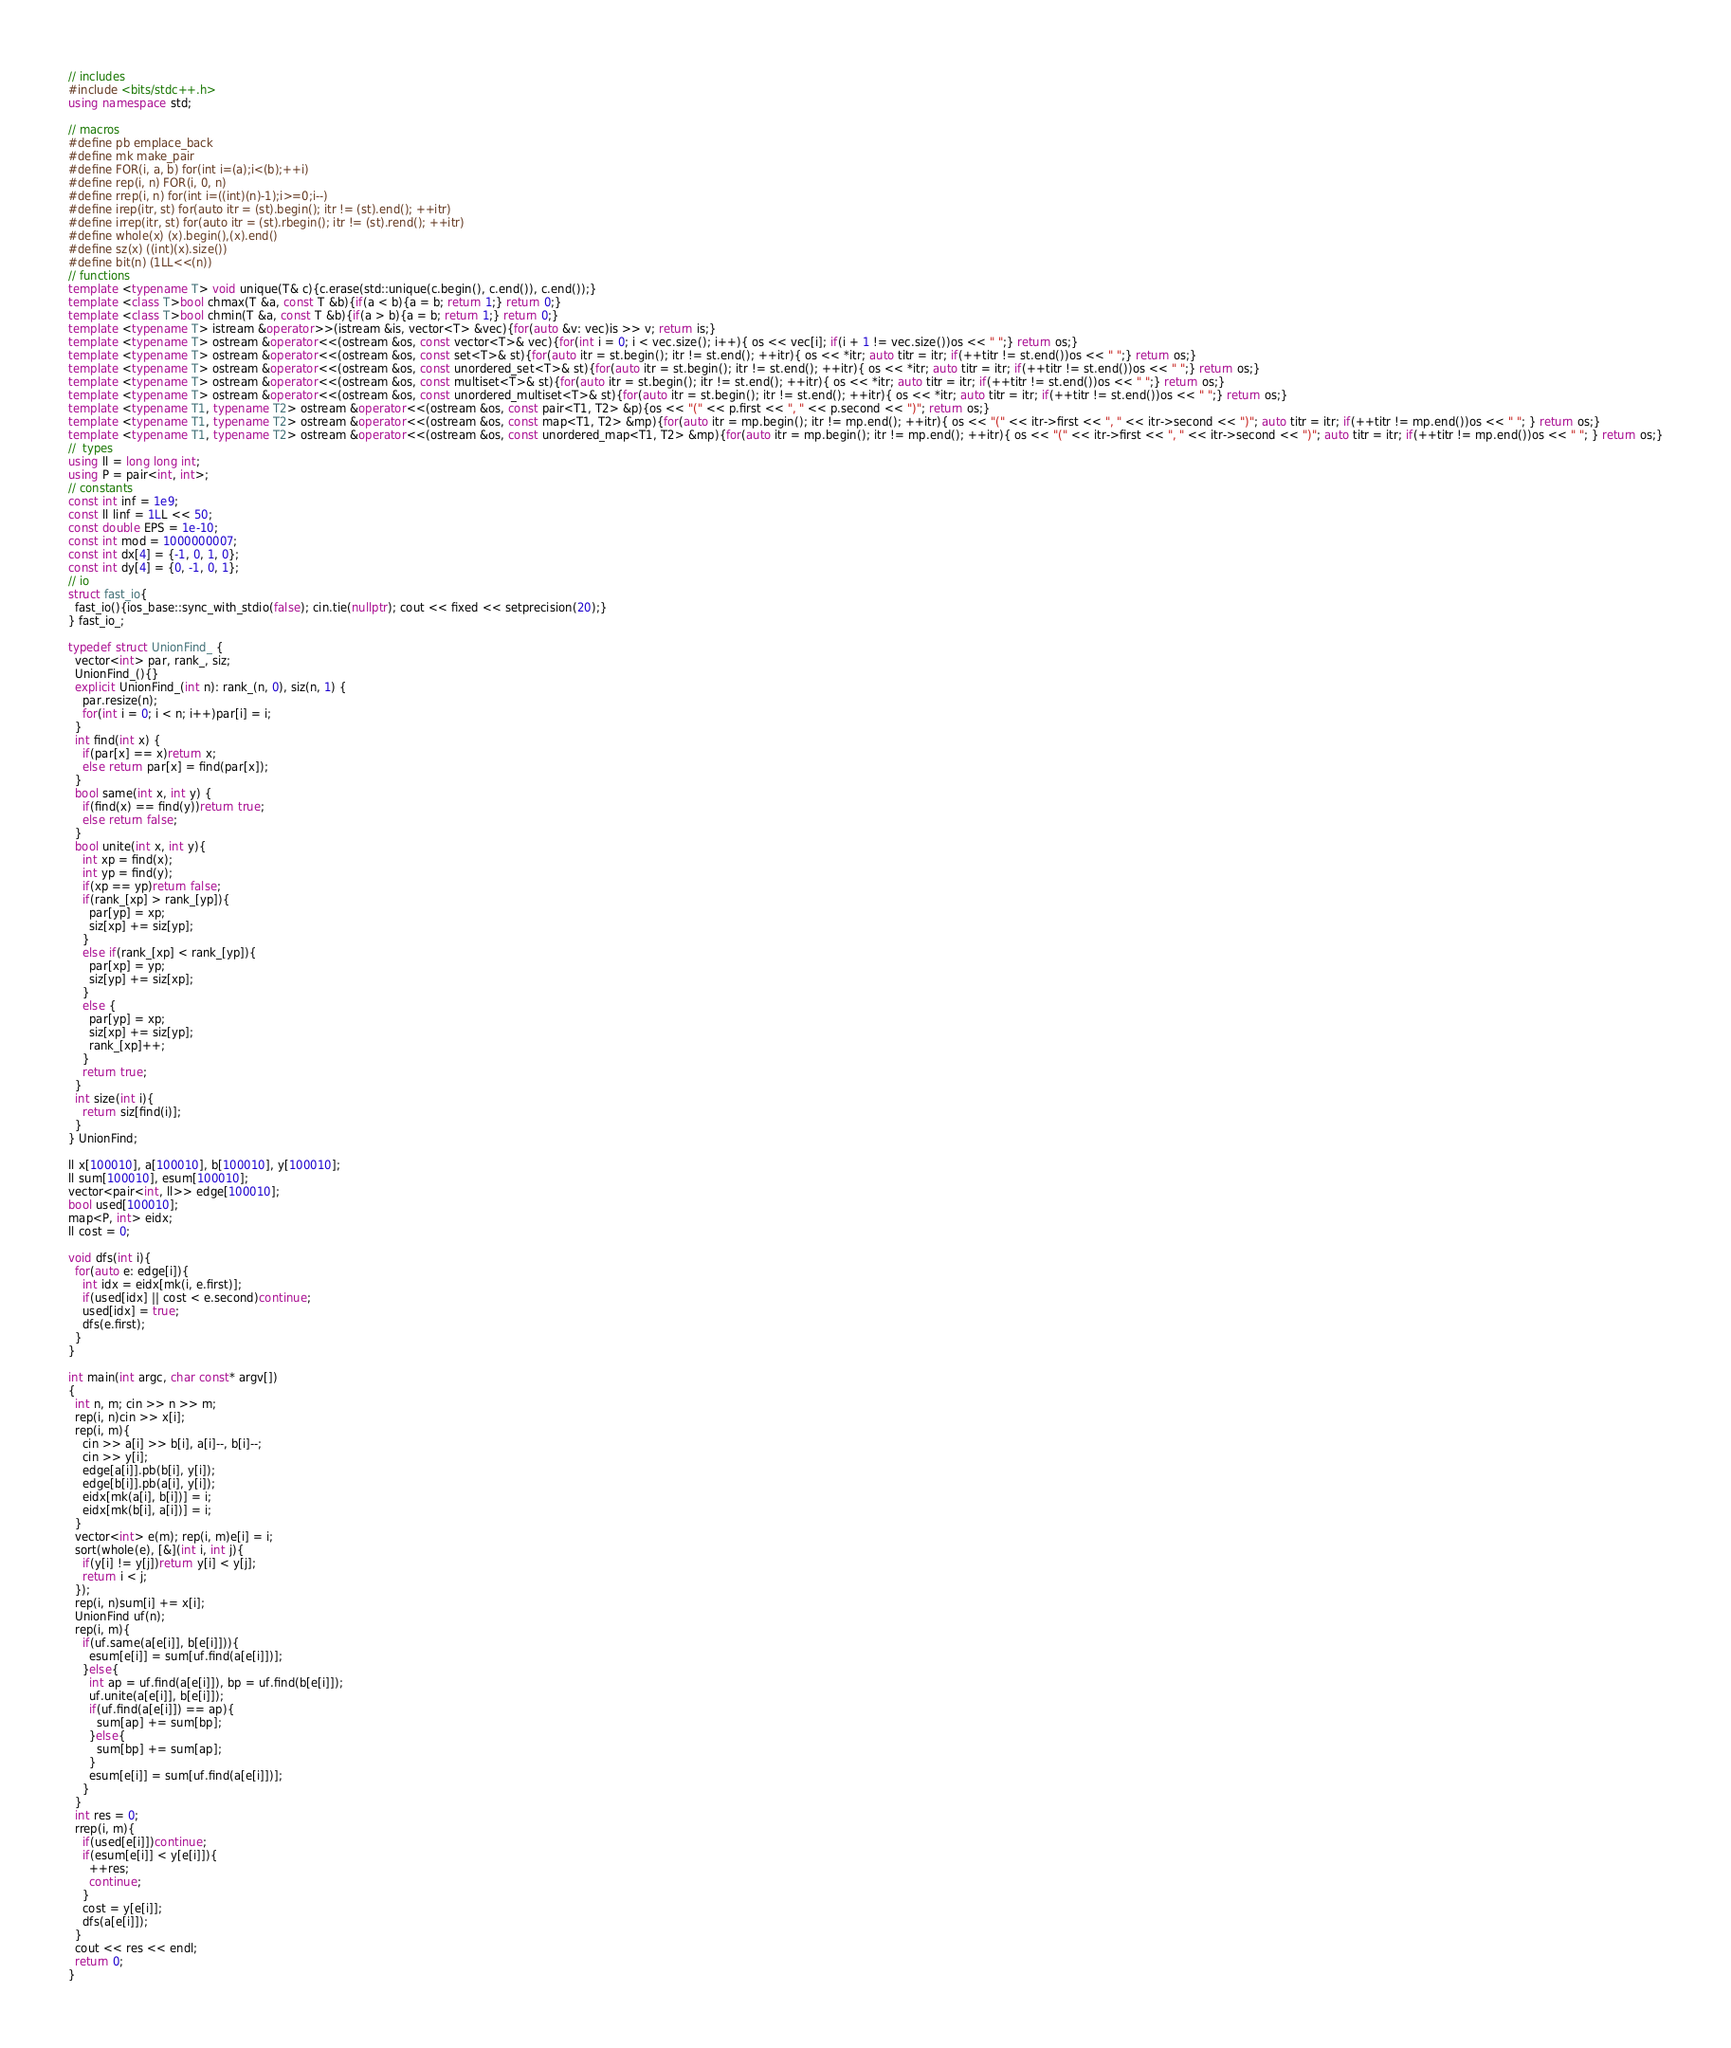<code> <loc_0><loc_0><loc_500><loc_500><_C++_>// includes
#include <bits/stdc++.h>
using namespace std;

// macros
#define pb emplace_back
#define mk make_pair
#define FOR(i, a, b) for(int i=(a);i<(b);++i)
#define rep(i, n) FOR(i, 0, n)
#define rrep(i, n) for(int i=((int)(n)-1);i>=0;i--)
#define irep(itr, st) for(auto itr = (st).begin(); itr != (st).end(); ++itr)
#define irrep(itr, st) for(auto itr = (st).rbegin(); itr != (st).rend(); ++itr)
#define whole(x) (x).begin(),(x).end()
#define sz(x) ((int)(x).size())
#define bit(n) (1LL<<(n))
// functions
template <typename T> void unique(T& c){c.erase(std::unique(c.begin(), c.end()), c.end());}
template <class T>bool chmax(T &a, const T &b){if(a < b){a = b; return 1;} return 0;}
template <class T>bool chmin(T &a, const T &b){if(a > b){a = b; return 1;} return 0;}
template <typename T> istream &operator>>(istream &is, vector<T> &vec){for(auto &v: vec)is >> v; return is;}
template <typename T> ostream &operator<<(ostream &os, const vector<T>& vec){for(int i = 0; i < vec.size(); i++){ os << vec[i]; if(i + 1 != vec.size())os << " ";} return os;}
template <typename T> ostream &operator<<(ostream &os, const set<T>& st){for(auto itr = st.begin(); itr != st.end(); ++itr){ os << *itr; auto titr = itr; if(++titr != st.end())os << " ";} return os;}
template <typename T> ostream &operator<<(ostream &os, const unordered_set<T>& st){for(auto itr = st.begin(); itr != st.end(); ++itr){ os << *itr; auto titr = itr; if(++titr != st.end())os << " ";} return os;}
template <typename T> ostream &operator<<(ostream &os, const multiset<T>& st){for(auto itr = st.begin(); itr != st.end(); ++itr){ os << *itr; auto titr = itr; if(++titr != st.end())os << " ";} return os;}
template <typename T> ostream &operator<<(ostream &os, const unordered_multiset<T>& st){for(auto itr = st.begin(); itr != st.end(); ++itr){ os << *itr; auto titr = itr; if(++titr != st.end())os << " ";} return os;}
template <typename T1, typename T2> ostream &operator<<(ostream &os, const pair<T1, T2> &p){os << "(" << p.first << ", " << p.second << ")"; return os;}
template <typename T1, typename T2> ostream &operator<<(ostream &os, const map<T1, T2> &mp){for(auto itr = mp.begin(); itr != mp.end(); ++itr){ os << "(" << itr->first << ", " << itr->second << ")"; auto titr = itr; if(++titr != mp.end())os << " "; } return os;}
template <typename T1, typename T2> ostream &operator<<(ostream &os, const unordered_map<T1, T2> &mp){for(auto itr = mp.begin(); itr != mp.end(); ++itr){ os << "(" << itr->first << ", " << itr->second << ")"; auto titr = itr; if(++titr != mp.end())os << " "; } return os;}
//  types
using ll = long long int;
using P = pair<int, int>;
// constants
const int inf = 1e9;
const ll linf = 1LL << 50;
const double EPS = 1e-10;
const int mod = 1000000007;
const int dx[4] = {-1, 0, 1, 0};
const int dy[4] = {0, -1, 0, 1};
// io
struct fast_io{
  fast_io(){ios_base::sync_with_stdio(false); cin.tie(nullptr); cout << fixed << setprecision(20);}
} fast_io_;

typedef struct UnionFind_ {
  vector<int> par, rank_, siz;
  UnionFind_(){}
  explicit UnionFind_(int n): rank_(n, 0), siz(n, 1) {
    par.resize(n);
    for(int i = 0; i < n; i++)par[i] = i;
  }
  int find(int x) {
    if(par[x] == x)return x;
    else return par[x] = find(par[x]);
  }
  bool same(int x, int y) {
    if(find(x) == find(y))return true;
    else return false;
  }
  bool unite(int x, int y){
    int xp = find(x);
    int yp = find(y);
    if(xp == yp)return false;
    if(rank_[xp] > rank_[yp]){
      par[yp] = xp;
      siz[xp] += siz[yp];
    }
    else if(rank_[xp] < rank_[yp]){
      par[xp] = yp;
      siz[yp] += siz[xp];
    }
    else {
      par[yp] = xp;
      siz[xp] += siz[yp];
      rank_[xp]++;
    }
    return true;
  }
  int size(int i){
    return siz[find(i)];
  }
} UnionFind;

ll x[100010], a[100010], b[100010], y[100010];
ll sum[100010], esum[100010];
vector<pair<int, ll>> edge[100010];
bool used[100010];
map<P, int> eidx;
ll cost = 0;

void dfs(int i){
  for(auto e: edge[i]){
    int idx = eidx[mk(i, e.first)];
    if(used[idx] || cost < e.second)continue;
    used[idx] = true;
    dfs(e.first);
  }
}

int main(int argc, char const* argv[])
{
  int n, m; cin >> n >> m;
  rep(i, n)cin >> x[i];
  rep(i, m){
    cin >> a[i] >> b[i], a[i]--, b[i]--;
    cin >> y[i];
    edge[a[i]].pb(b[i], y[i]);
    edge[b[i]].pb(a[i], y[i]);
    eidx[mk(a[i], b[i])] = i;
    eidx[mk(b[i], a[i])] = i;
  }
  vector<int> e(m); rep(i, m)e[i] = i;
  sort(whole(e), [&](int i, int j){
    if(y[i] != y[j])return y[i] < y[j];
    return i < j;
  });
  rep(i, n)sum[i] += x[i];
  UnionFind uf(n);
  rep(i, m){
    if(uf.same(a[e[i]], b[e[i]])){
      esum[e[i]] = sum[uf.find(a[e[i]])];
    }else{
      int ap = uf.find(a[e[i]]), bp = uf.find(b[e[i]]);
      uf.unite(a[e[i]], b[e[i]]);
      if(uf.find(a[e[i]]) == ap){
        sum[ap] += sum[bp];
      }else{
        sum[bp] += sum[ap];
      }
      esum[e[i]] = sum[uf.find(a[e[i]])];
    }
  }
  int res = 0;
  rrep(i, m){
    if(used[e[i]])continue;
    if(esum[e[i]] < y[e[i]]){
      ++res;
      continue;
    }
    cost = y[e[i]];
    dfs(a[e[i]]);
  }
  cout << res << endl;
  return 0;
}
</code> 